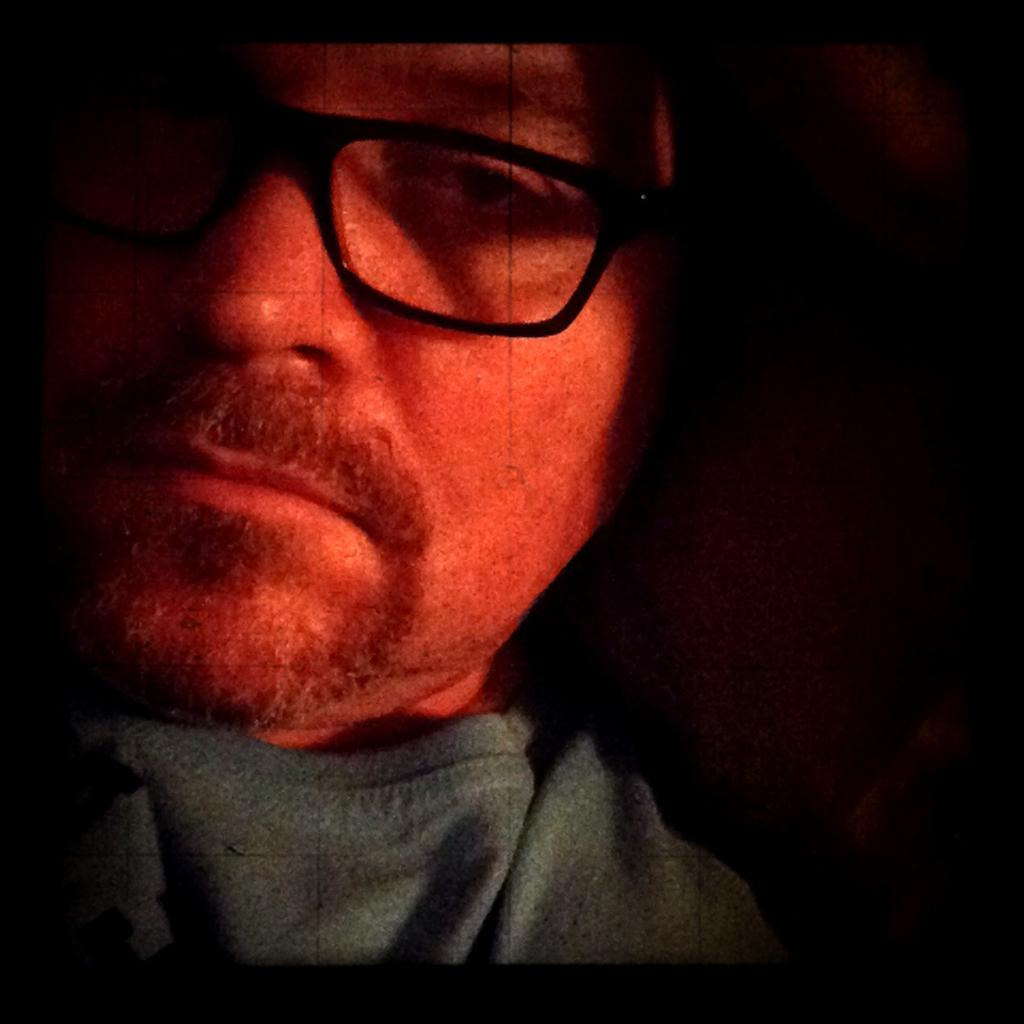What is the main subject of the image? There is a person in the image. What can be observed about the person's appearance? The person is wearing spectacles. What is the color or lighting of the background in the image? The background of the image is dark. What year is depicted in the image? There is no specific year depicted in the image; it is a photograph or illustration of a person wearing spectacles against a dark background. Which direction is the person facing in the image? The provided facts do not mention the direction the person is facing, so it cannot be determined from the image. 